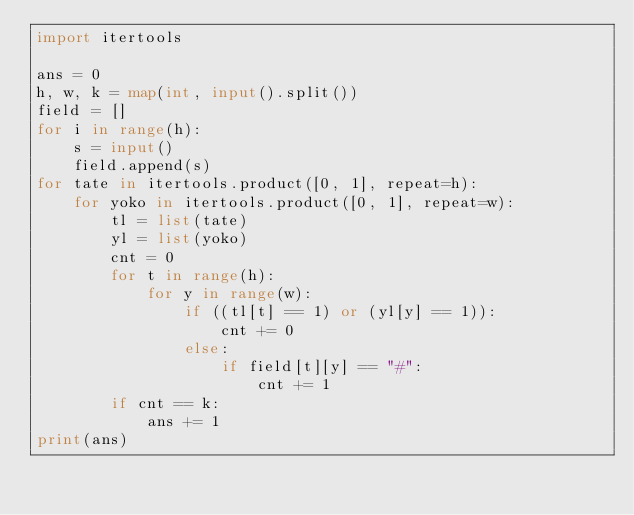<code> <loc_0><loc_0><loc_500><loc_500><_Python_>import itertools

ans = 0
h, w, k = map(int, input().split())
field = []
for i in range(h):
    s = input()
    field.append(s)
for tate in itertools.product([0, 1], repeat=h):
    for yoko in itertools.product([0, 1], repeat=w):
        tl = list(tate)
        yl = list(yoko)
        cnt = 0
        for t in range(h):
            for y in range(w):
                if ((tl[t] == 1) or (yl[y] == 1)):
                    cnt += 0
                else:
                    if field[t][y] == "#":
                        cnt += 1
        if cnt == k:
            ans += 1
print(ans)
</code> 